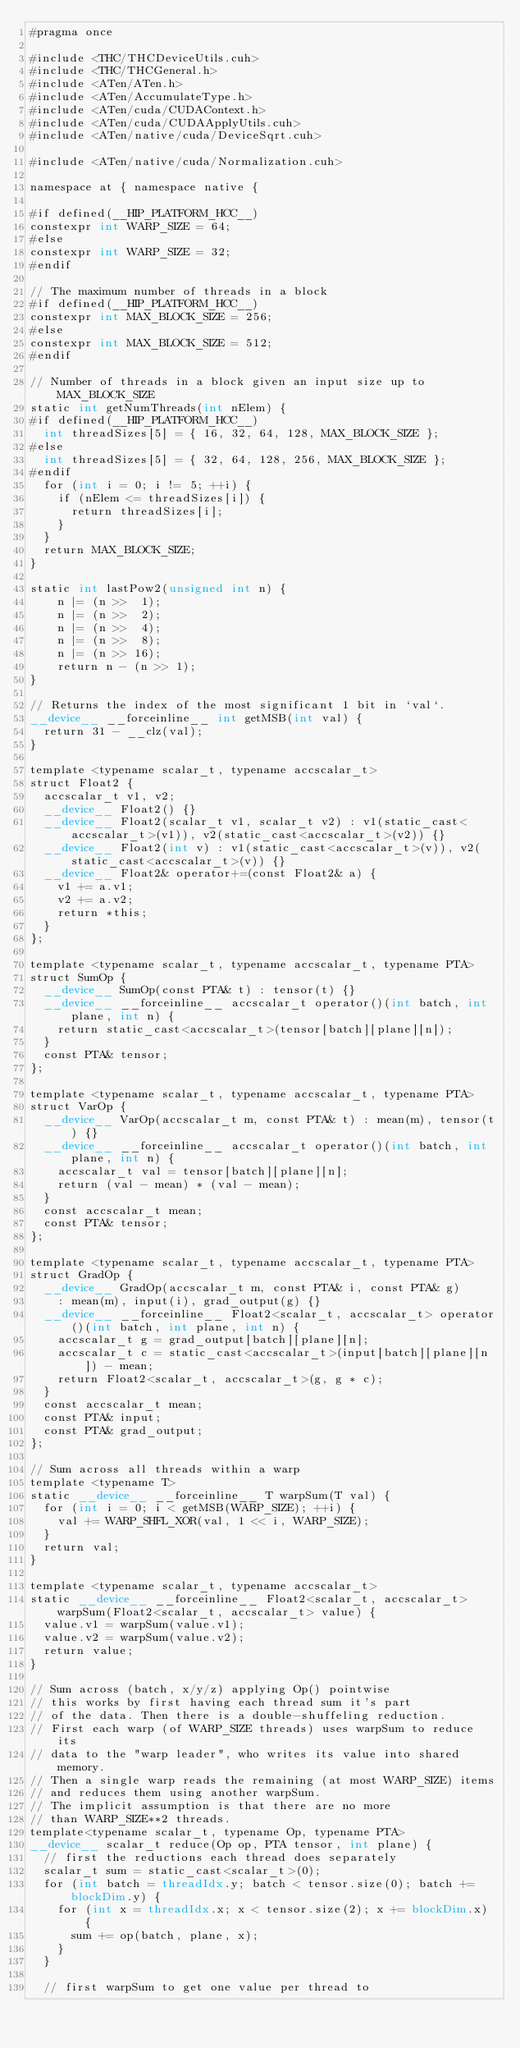<code> <loc_0><loc_0><loc_500><loc_500><_Cuda_>#pragma once

#include <THC/THCDeviceUtils.cuh>
#include <THC/THCGeneral.h>
#include <ATen/ATen.h>
#include <ATen/AccumulateType.h>
#include <ATen/cuda/CUDAContext.h>
#include <ATen/cuda/CUDAApplyUtils.cuh>
#include <ATen/native/cuda/DeviceSqrt.cuh>

#include <ATen/native/cuda/Normalization.cuh>

namespace at { namespace native {

#if defined(__HIP_PLATFORM_HCC__)
constexpr int WARP_SIZE = 64;
#else
constexpr int WARP_SIZE = 32;
#endif

// The maximum number of threads in a block
#if defined(__HIP_PLATFORM_HCC__)
constexpr int MAX_BLOCK_SIZE = 256;
#else
constexpr int MAX_BLOCK_SIZE = 512;
#endif

// Number of threads in a block given an input size up to MAX_BLOCK_SIZE
static int getNumThreads(int nElem) {
#if defined(__HIP_PLATFORM_HCC__)
  int threadSizes[5] = { 16, 32, 64, 128, MAX_BLOCK_SIZE };
#else
  int threadSizes[5] = { 32, 64, 128, 256, MAX_BLOCK_SIZE };
#endif
  for (int i = 0; i != 5; ++i) {
    if (nElem <= threadSizes[i]) {
      return threadSizes[i];
    }
  }
  return MAX_BLOCK_SIZE;
}

static int lastPow2(unsigned int n) {
    n |= (n >>  1);
    n |= (n >>  2);
    n |= (n >>  4);
    n |= (n >>  8);
    n |= (n >> 16);
    return n - (n >> 1);
}

// Returns the index of the most significant 1 bit in `val`.
__device__ __forceinline__ int getMSB(int val) {
  return 31 - __clz(val);
}

template <typename scalar_t, typename accscalar_t>
struct Float2 {
  accscalar_t v1, v2;
  __device__ Float2() {}
  __device__ Float2(scalar_t v1, scalar_t v2) : v1(static_cast<accscalar_t>(v1)), v2(static_cast<accscalar_t>(v2)) {}
  __device__ Float2(int v) : v1(static_cast<accscalar_t>(v)), v2(static_cast<accscalar_t>(v)) {}
  __device__ Float2& operator+=(const Float2& a) {
    v1 += a.v1;
    v2 += a.v2;
    return *this;
  }
};

template <typename scalar_t, typename accscalar_t, typename PTA>
struct SumOp {
  __device__ SumOp(const PTA& t) : tensor(t) {}
  __device__ __forceinline__ accscalar_t operator()(int batch, int plane, int n) {
    return static_cast<accscalar_t>(tensor[batch][plane][n]);
  }
  const PTA& tensor;
};

template <typename scalar_t, typename accscalar_t, typename PTA>
struct VarOp {
  __device__ VarOp(accscalar_t m, const PTA& t) : mean(m), tensor(t) {}
  __device__ __forceinline__ accscalar_t operator()(int batch, int plane, int n) {
    accscalar_t val = tensor[batch][plane][n];
    return (val - mean) * (val - mean);
  }
  const accscalar_t mean;
  const PTA& tensor;
};

template <typename scalar_t, typename accscalar_t, typename PTA>
struct GradOp {
  __device__ GradOp(accscalar_t m, const PTA& i, const PTA& g)
    : mean(m), input(i), grad_output(g) {}
  __device__ __forceinline__ Float2<scalar_t, accscalar_t> operator()(int batch, int plane, int n) {
    accscalar_t g = grad_output[batch][plane][n];
    accscalar_t c = static_cast<accscalar_t>(input[batch][plane][n]) - mean;
    return Float2<scalar_t, accscalar_t>(g, g * c);
  }
  const accscalar_t mean;
  const PTA& input;
  const PTA& grad_output;
};

// Sum across all threads within a warp
template <typename T>
static __device__ __forceinline__ T warpSum(T val) {
  for (int i = 0; i < getMSB(WARP_SIZE); ++i) {
    val += WARP_SHFL_XOR(val, 1 << i, WARP_SIZE);
  }
  return val;
}

template <typename scalar_t, typename accscalar_t>
static __device__ __forceinline__ Float2<scalar_t, accscalar_t> warpSum(Float2<scalar_t, accscalar_t> value) {
  value.v1 = warpSum(value.v1);
  value.v2 = warpSum(value.v2);
  return value;
}

// Sum across (batch, x/y/z) applying Op() pointwise
// this works by first having each thread sum it's part
// of the data. Then there is a double-shuffeling reduction.
// First each warp (of WARP_SIZE threads) uses warpSum to reduce its
// data to the "warp leader", who writes its value into shared memory.
// Then a single warp reads the remaining (at most WARP_SIZE) items
// and reduces them using another warpSum.
// The implicit assumption is that there are no more
// than WARP_SIZE**2 threads.
template<typename scalar_t, typename Op, typename PTA>
__device__ scalar_t reduce(Op op, PTA tensor, int plane) {
  // first the reductions each thread does separately
  scalar_t sum = static_cast<scalar_t>(0);
  for (int batch = threadIdx.y; batch < tensor.size(0); batch += blockDim.y) {
    for (int x = threadIdx.x; x < tensor.size(2); x += blockDim.x) {
      sum += op(batch, plane, x);
    }
  }

  // first warpSum to get one value per thread to</code> 